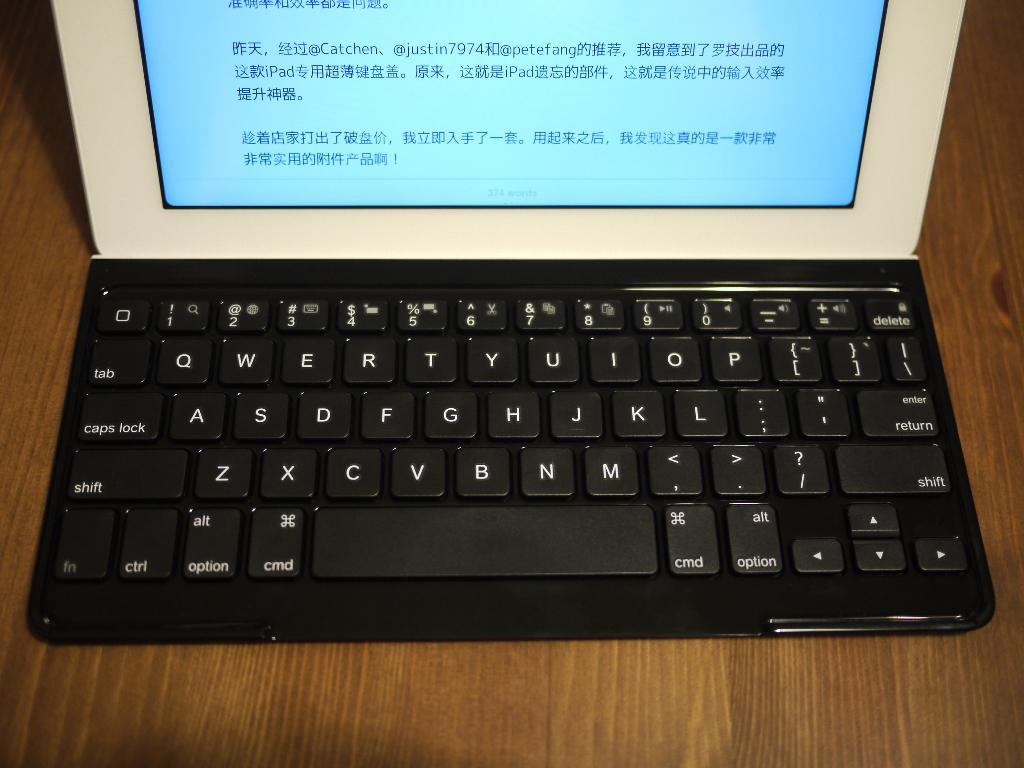<image>
Offer a succinct explanation of the picture presented. The laptop has foreign words on the screen. 